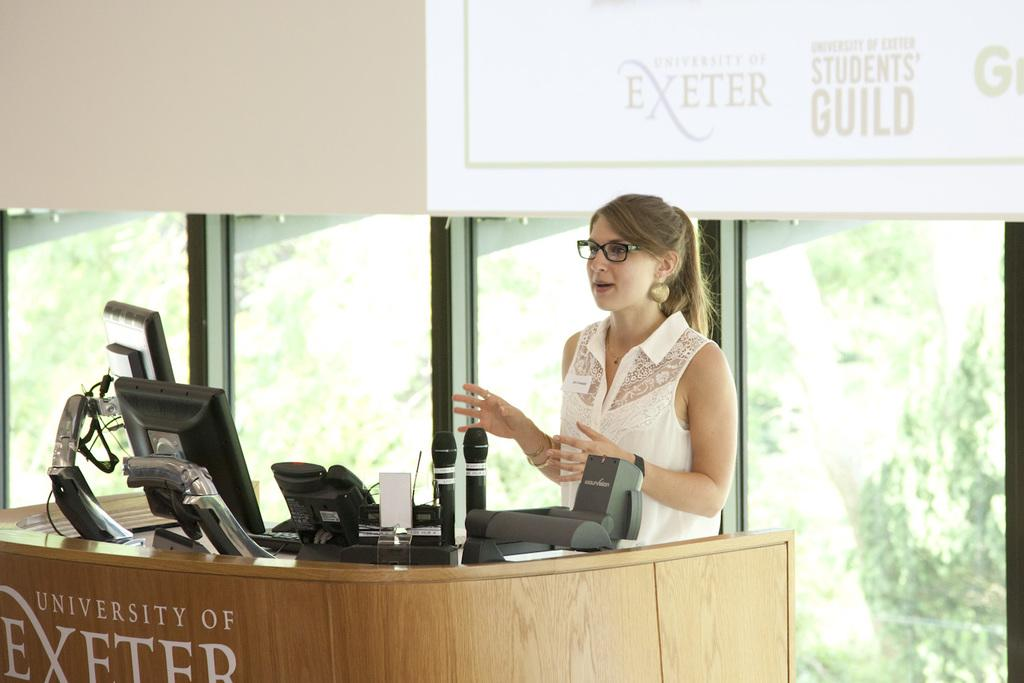What is the person in the image doing? The person is standing in front of a table. What is on the table in the image? There is a system and microphones on the table. What can be seen in the background of the image? There is a board and a glass object in the background. What type of scene is being depicted in the image? The image does not depict a scene; it is a photograph of a person standing in front of a table with various objects. What organization is responsible for the system on the table? The image does not provide any information about the organization responsible for the system on the table. 